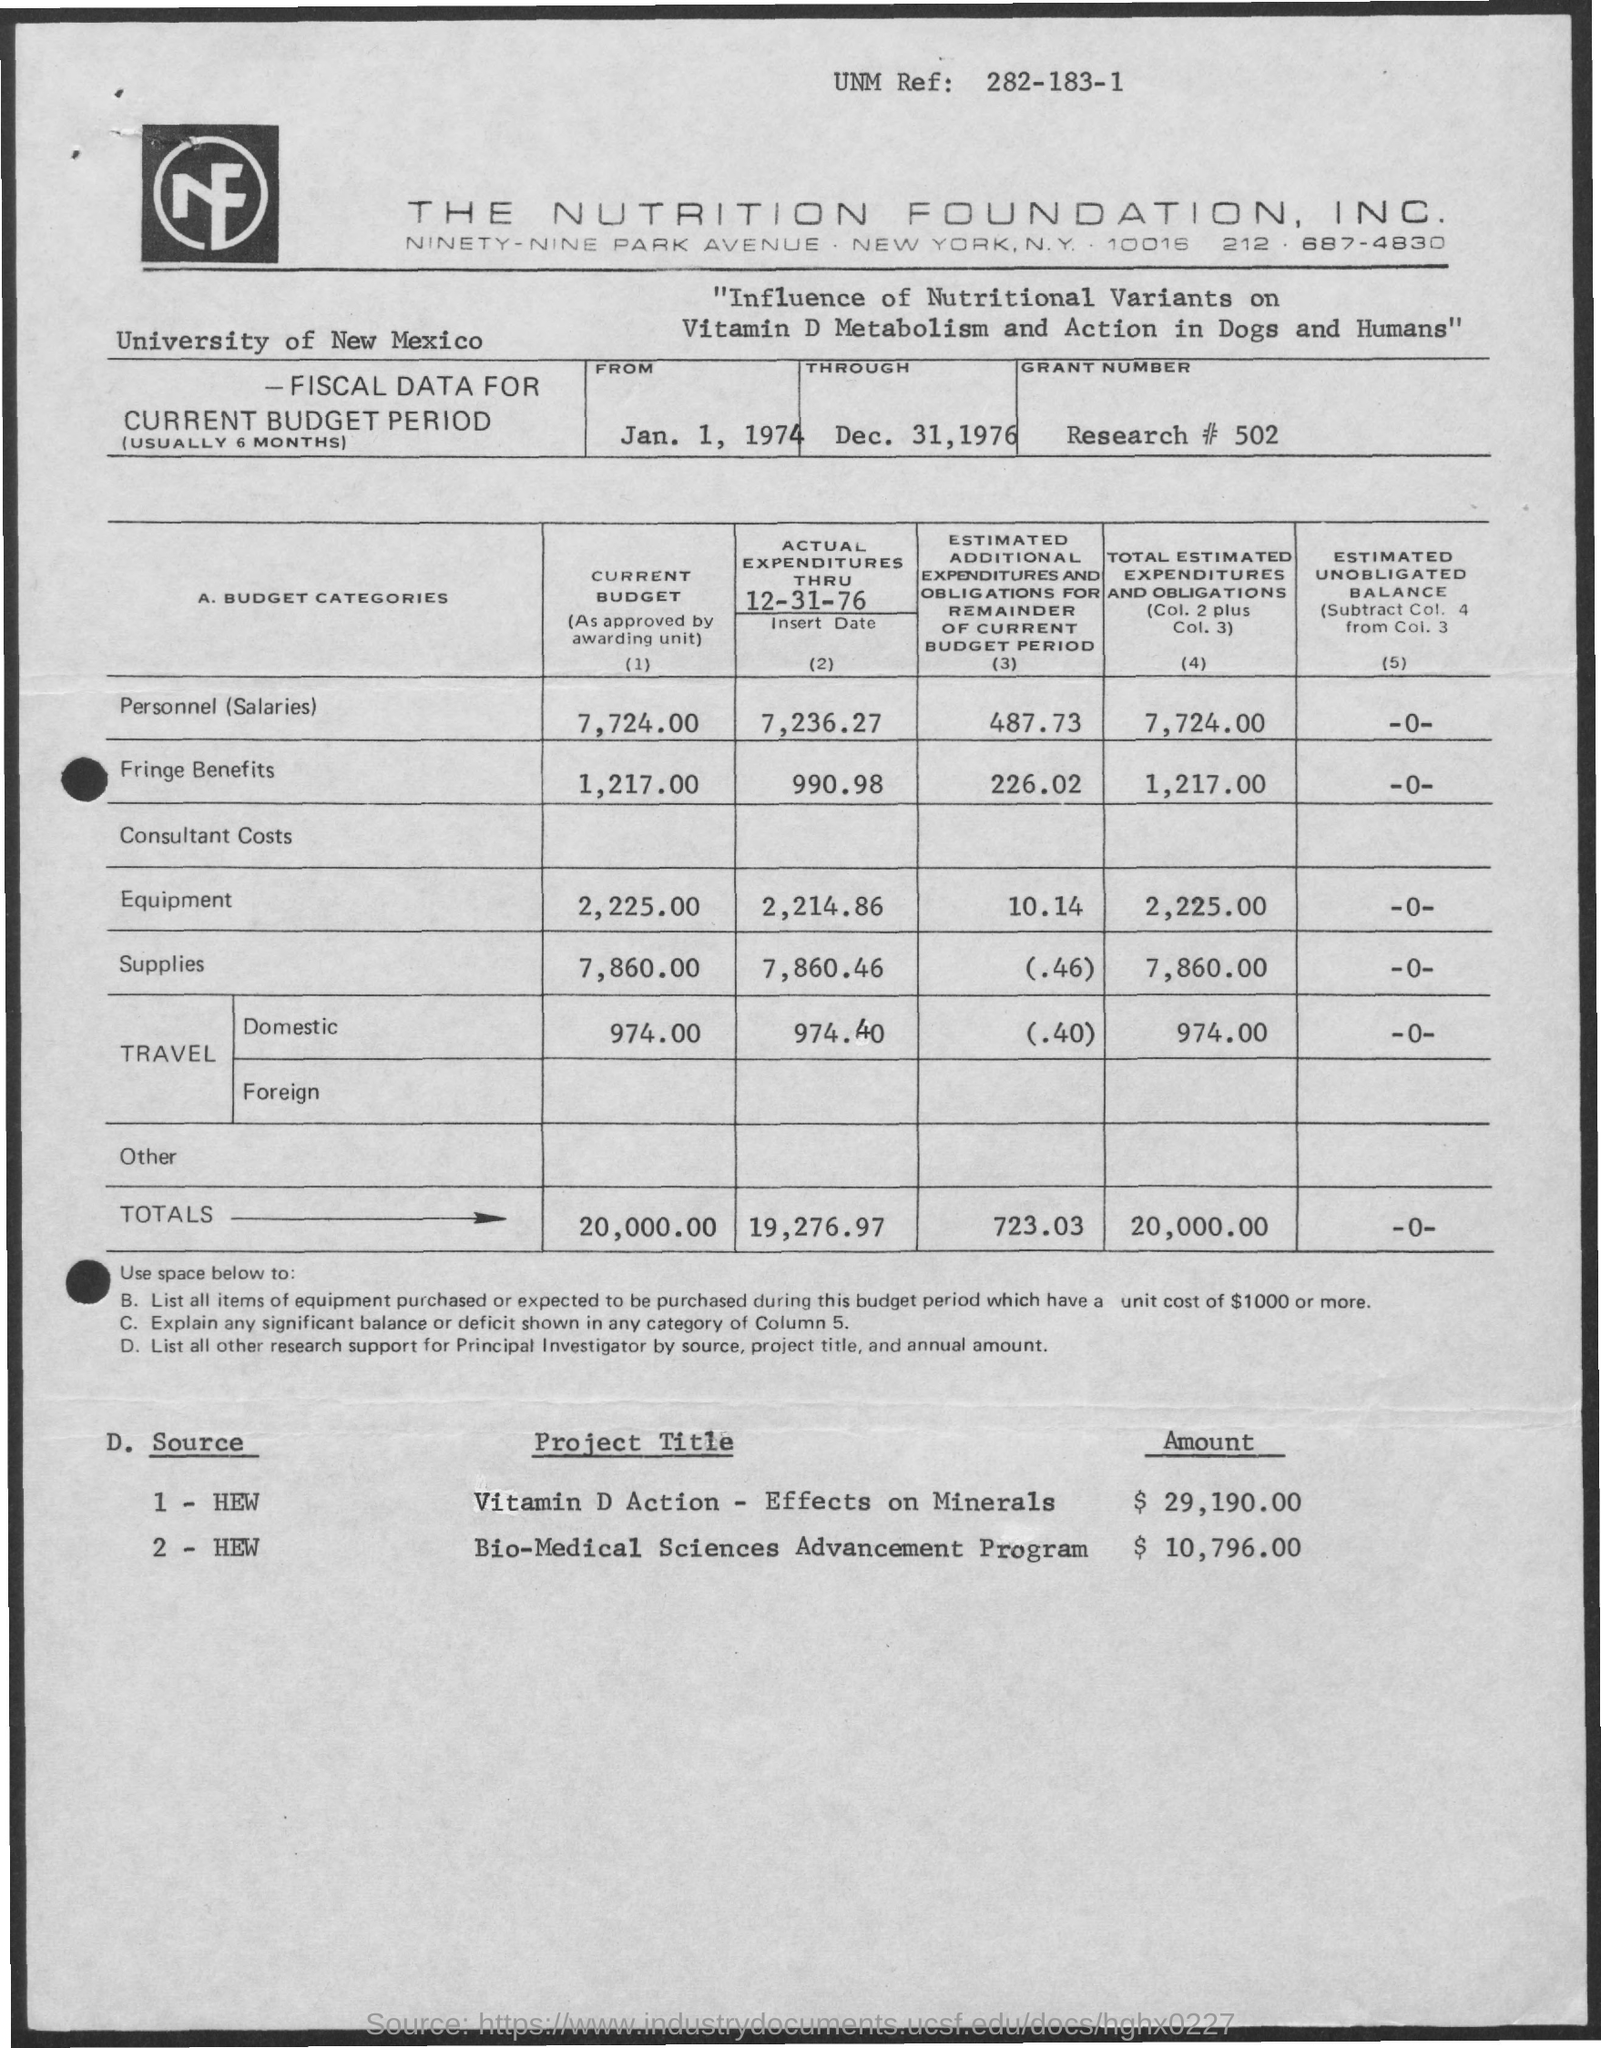List a handful of essential elements in this visual. The actual expenditures for equipment through December 31, 1976, were $2,214.86. The total amount shown in the current budget is 20,000.00. The estimated additional expenditures and obligations for the remainder of the current budget period are $723.03. The amount required to elicit the effects of vitamin D on minerals is approximately $29,190.00. The amount of fringe benefits in the current budget is 1,217.00. 